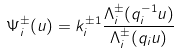Convert formula to latex. <formula><loc_0><loc_0><loc_500><loc_500>\Psi _ { i } ^ { \pm } ( u ) = k _ { i } ^ { \pm 1 } \frac { \Lambda _ { i } ^ { \pm } ( q _ { i } ^ { - 1 } u ) } { \Lambda _ { i } ^ { \pm } ( q _ { i } u ) }</formula> 